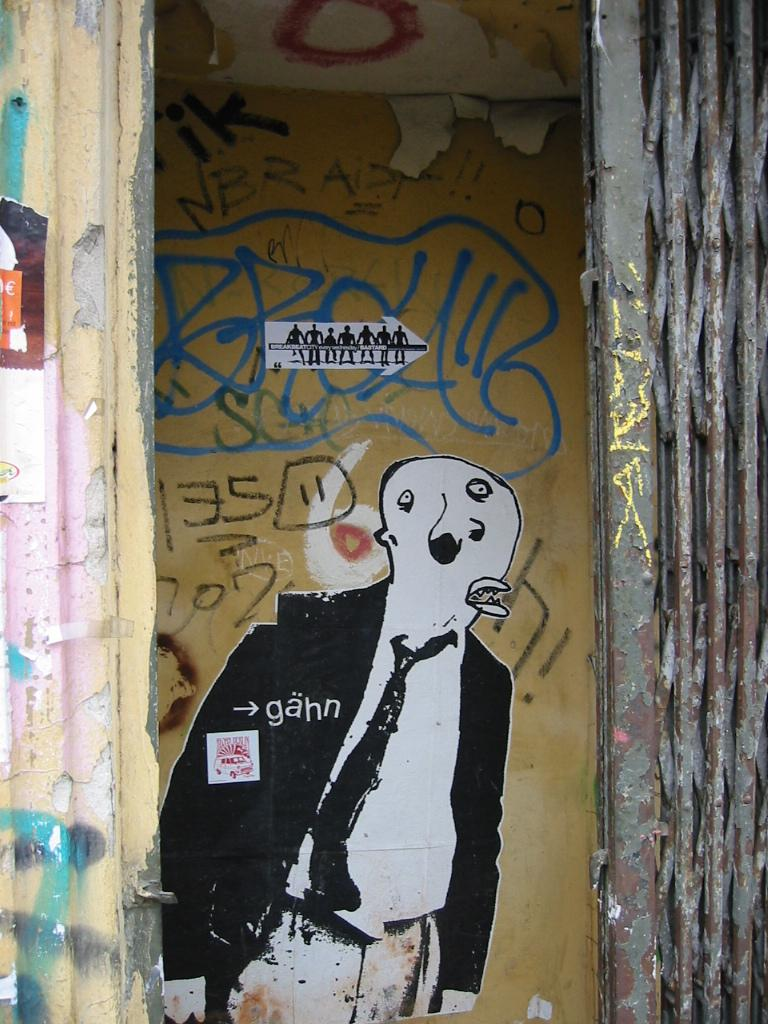What is the main structure visible in the image? There is a gate in the image. Can you describe anything else in the background of the image? There is a painting on the wall in the background of the image. What type of record can be heard playing in the background of the image? There is no record or sound present in the image; it is a still image of a gate and a painting on the wall. 